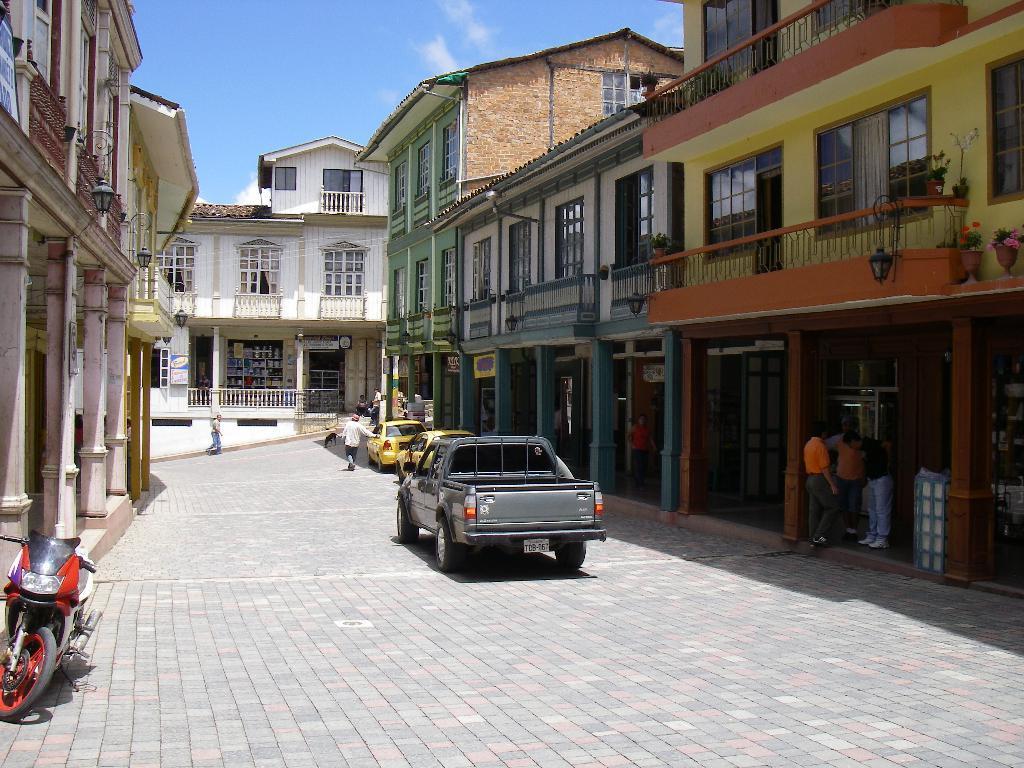How would you summarize this image in a sentence or two? In this image I can see the road, few vehicles on the road, few persons standing and few buildings on both sides of the road. In the background I can see the sky. 